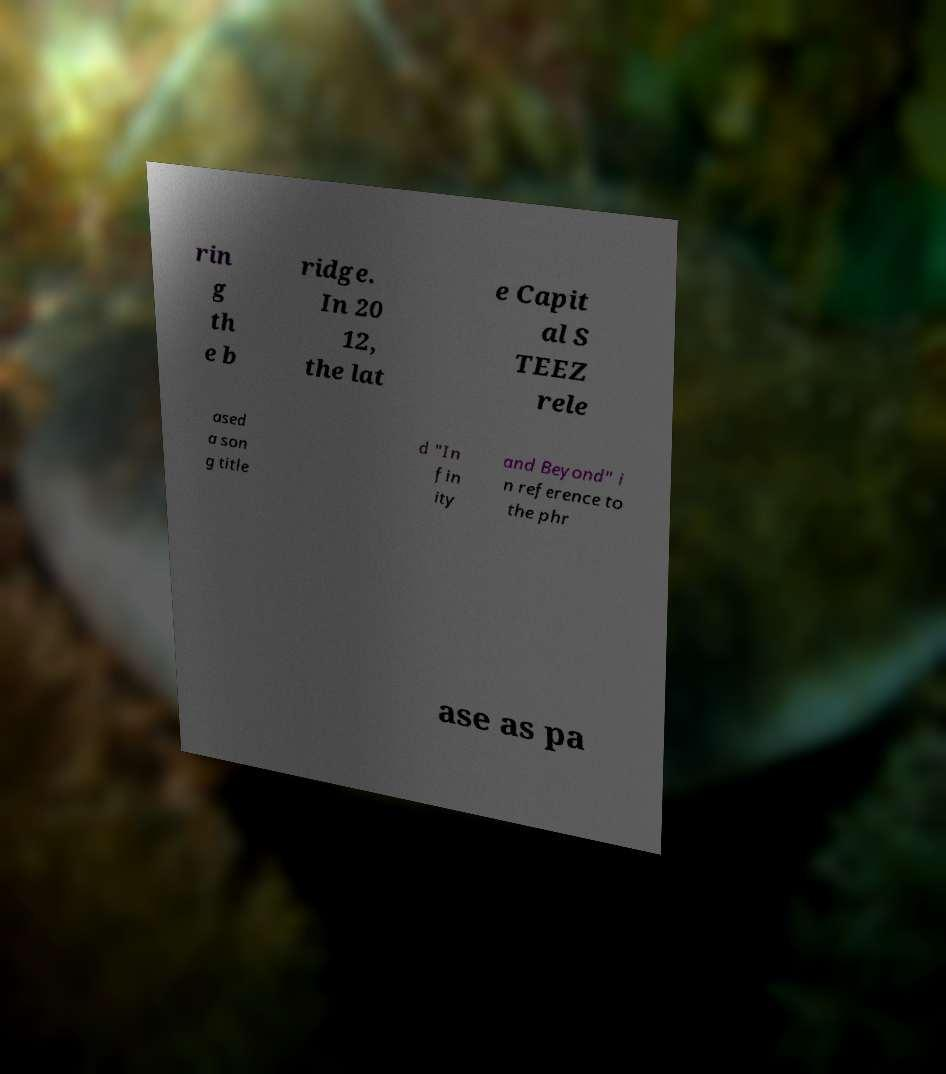There's text embedded in this image that I need extracted. Can you transcribe it verbatim? rin g th e b ridge. In 20 12, the lat e Capit al S TEEZ rele ased a son g title d "In fin ity and Beyond" i n reference to the phr ase as pa 